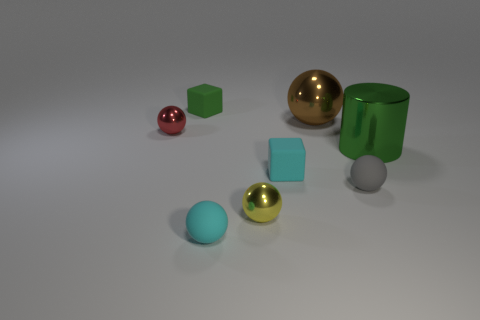Subtract all tiny red metal balls. How many balls are left? 4 Add 2 small matte cubes. How many objects exist? 10 Subtract all red balls. How many balls are left? 4 Subtract all cylinders. How many objects are left? 7 Subtract all cyan spheres. Subtract all gray cylinders. How many spheres are left? 4 Subtract all small red objects. Subtract all green shiny cylinders. How many objects are left? 6 Add 4 metallic cylinders. How many metallic cylinders are left? 5 Add 1 large cyan objects. How many large cyan objects exist? 1 Subtract 0 brown cubes. How many objects are left? 8 